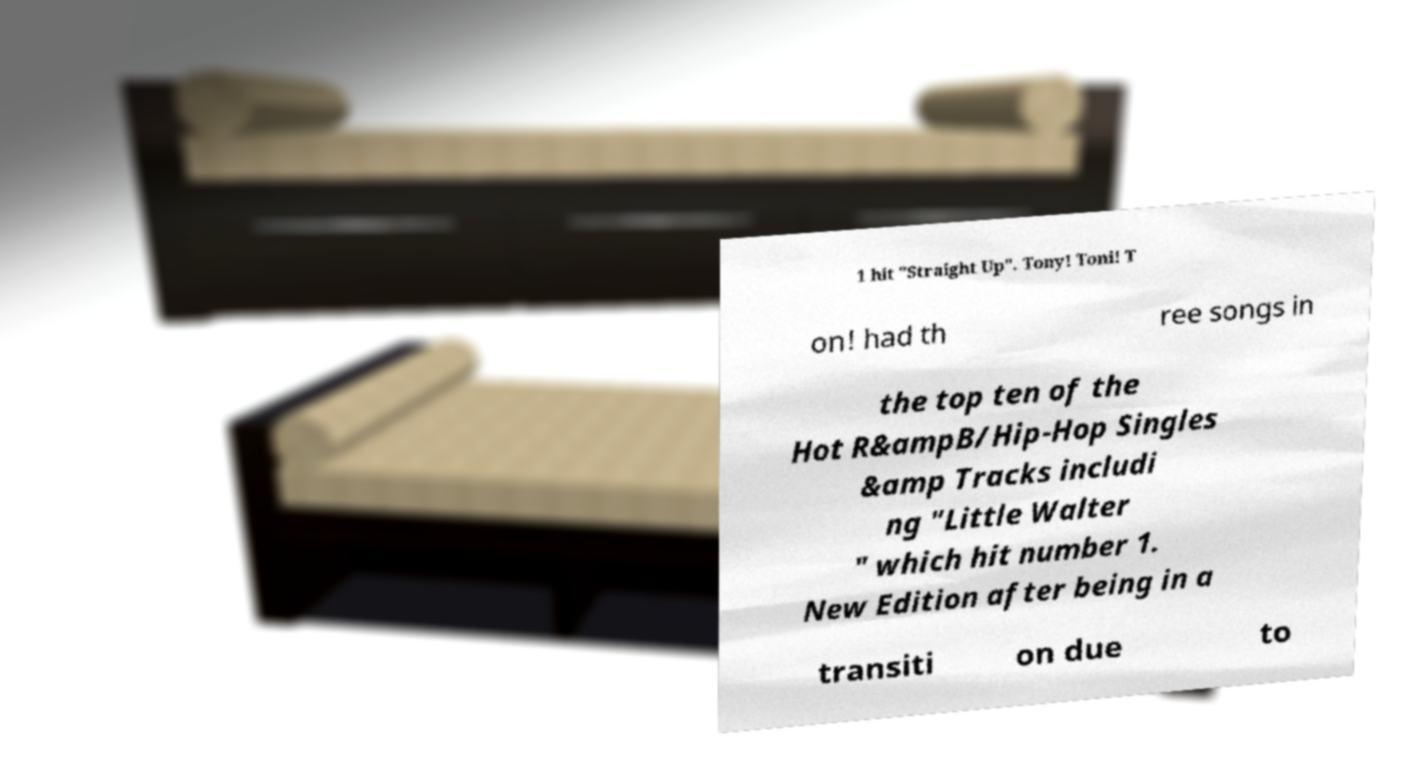What messages or text are displayed in this image? I need them in a readable, typed format. 1 hit "Straight Up". Tony! Toni! T on! had th ree songs in the top ten of the Hot R&ampB/Hip-Hop Singles &amp Tracks includi ng "Little Walter " which hit number 1. New Edition after being in a transiti on due to 